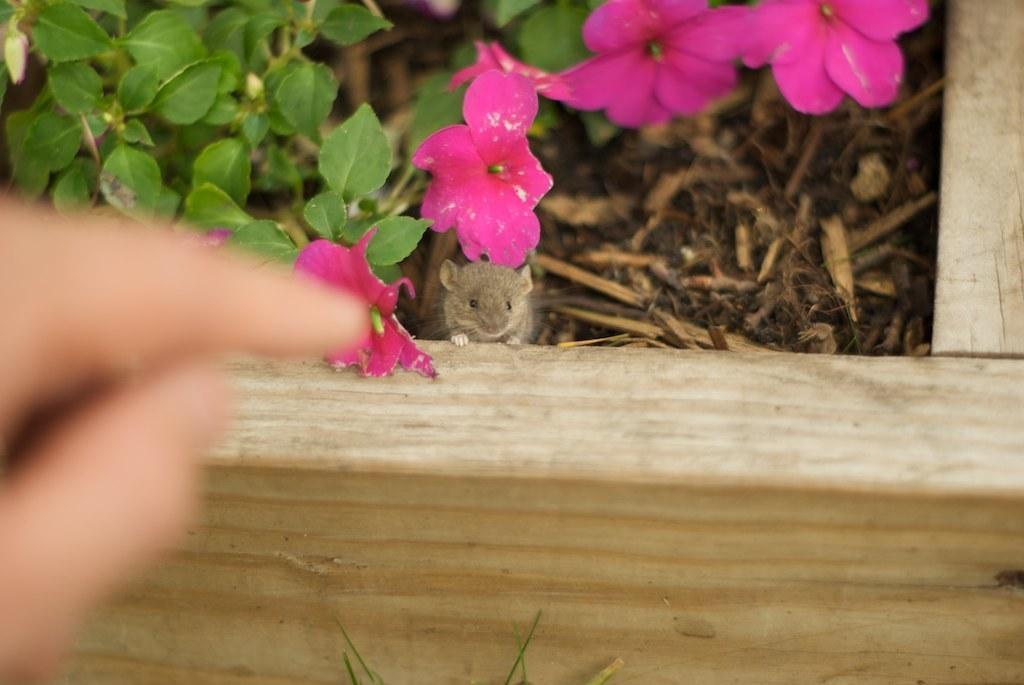Describe this image in one or two sentences. In this picture we can see a person's fingers and in the background we can see a wooden object, mice, plants with flowers and wooden sticks. 